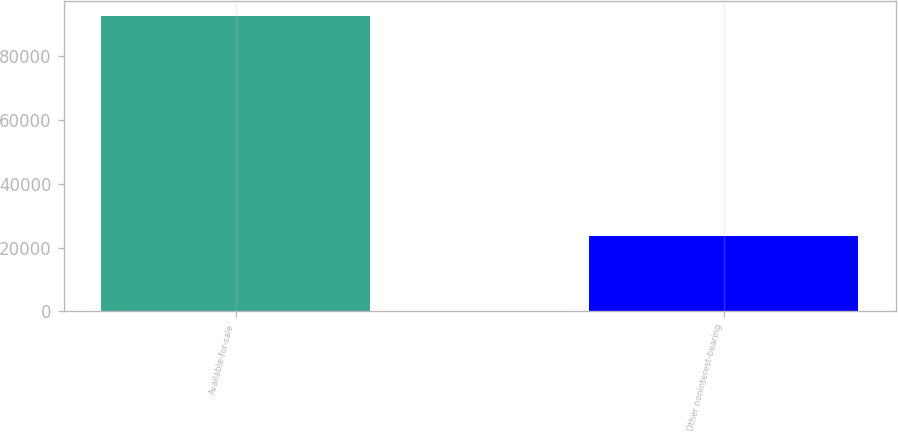<chart> <loc_0><loc_0><loc_500><loc_500><bar_chart><fcel>Available-for-sale<fcel>Other noninterest-bearing<nl><fcel>92525<fcel>23706<nl></chart> 